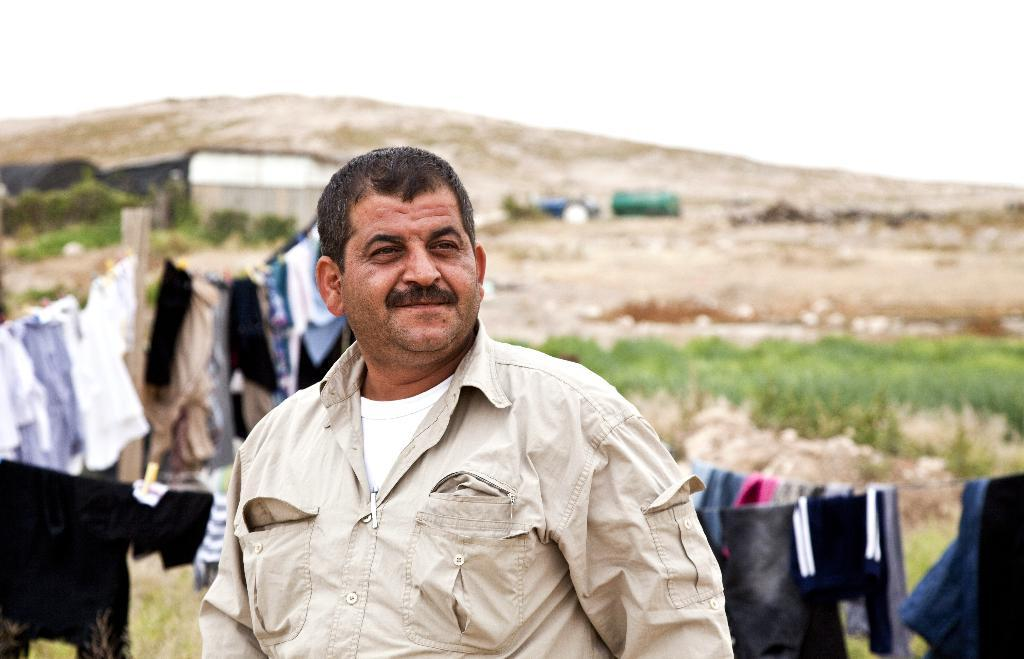What is the man in the image doing? The man is standing and smiling in the image. What is the man wearing in the image? The man is wearing a shirt in the image. What can be seen hanging in the image? Clothes hanging on ropes can be seen in the image. What is visible in the background of the image? In the background of the image, there is a hill, a house, and trees. What type of roof can be seen on the house in the image? There is no roof visible in the image, as only the house's outline is shown in the background. How does the sun affect the man's comfort in the image? The image does not provide information about the sun or the man's comfort, so we cannot determine its effect. 